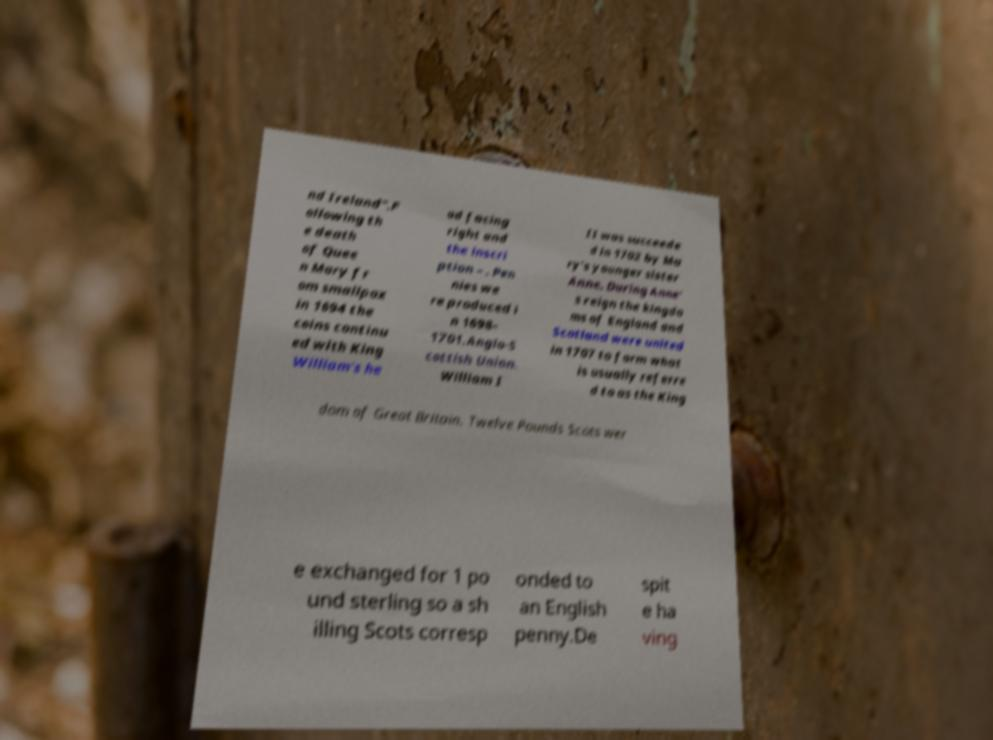Please read and relay the text visible in this image. What does it say? nd Ireland".F ollowing th e death of Quee n Mary fr om smallpox in 1694 the coins continu ed with King William's he ad facing right and the inscri ption – . Pen nies we re produced i n 1698– 1701.Anglo-S cottish Union. William I II was succeede d in 1702 by Ma ry's younger sister Anne. During Anne' s reign the kingdo ms of England and Scotland were united in 1707 to form what is usually referre d to as the King dom of Great Britain. Twelve Pounds Scots wer e exchanged for 1 po und sterling so a sh illing Scots corresp onded to an English penny.De spit e ha ving 